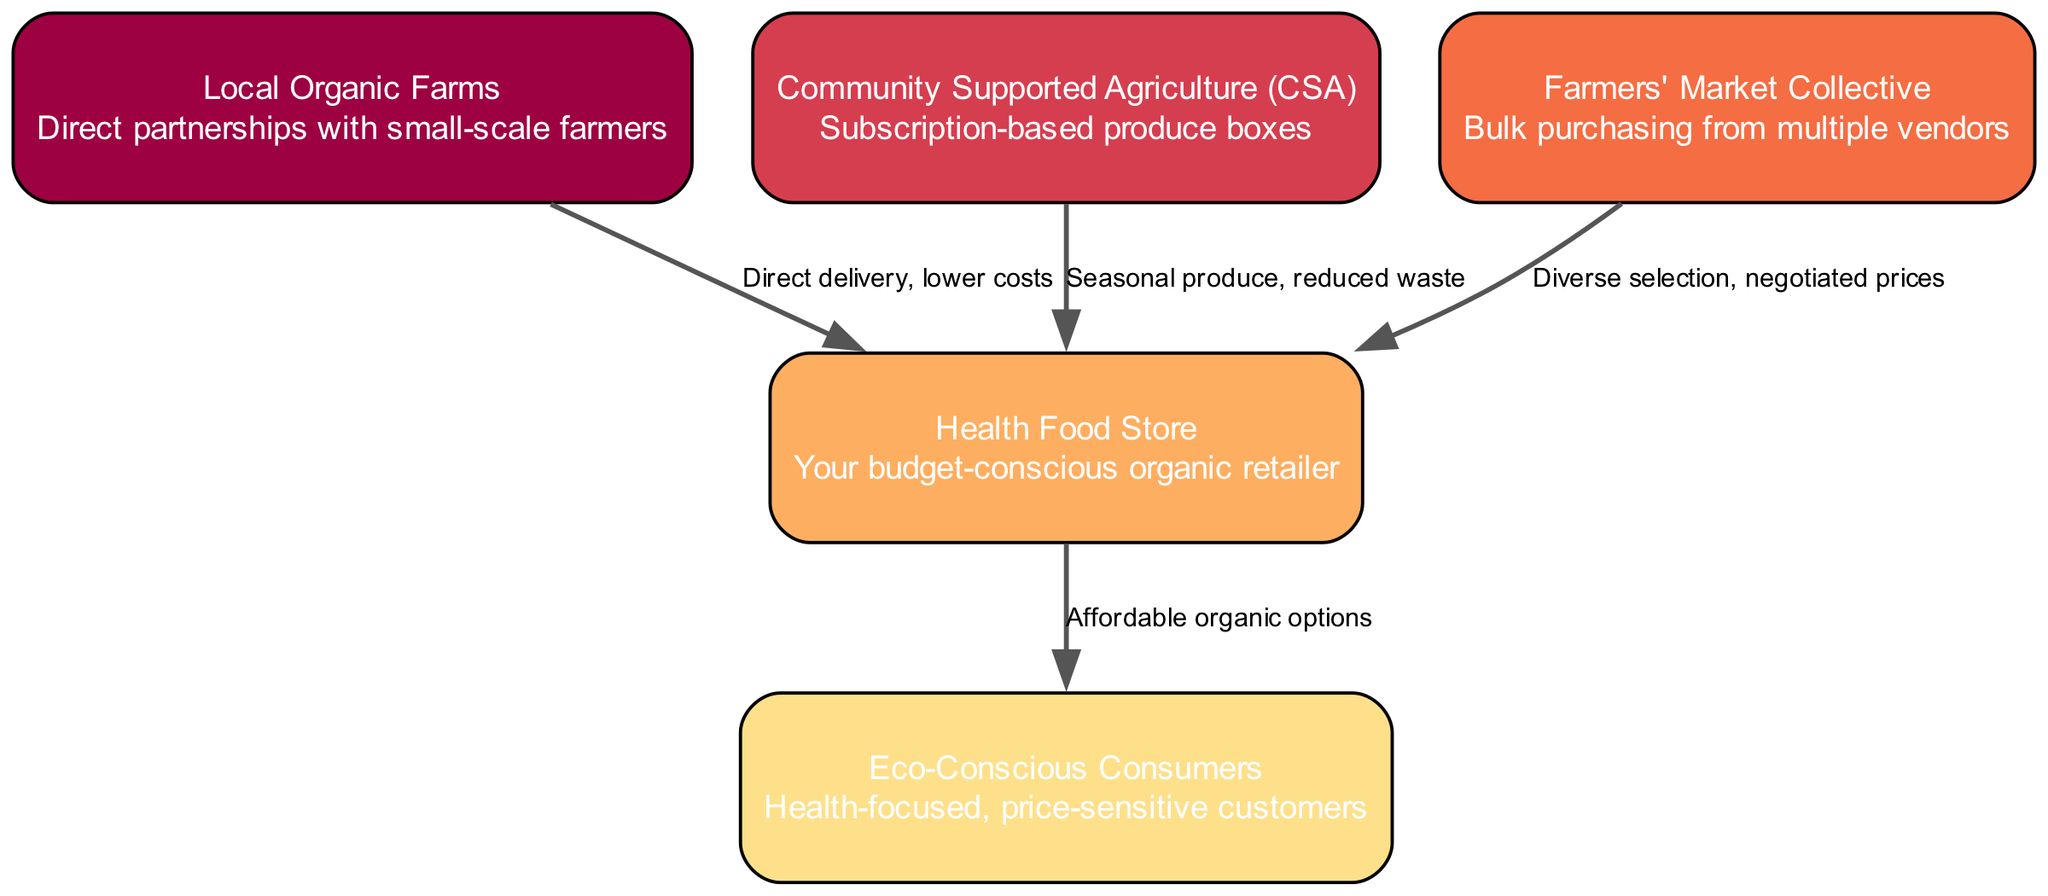What is the first node in the diagram? The first node in the diagram is "Local Organic Farms", as it is listed first in the nodes section.
Answer: Local Organic Farms How many nodes are there in the diagram? There are five nodes represented in the diagram: Local Organic Farms, Community Supported Agriculture, Farmers' Market Collective, Health Food Store, and Eco-Conscious Consumers.
Answer: 5 What relationship does "Local Organic Farms" have with "Health Food Store"? The relationship between "Local Organic Farms" and "Health Food Store" is described as "Direct delivery, lower costs", indicating a direct connection with cost benefits.
Answer: Direct delivery, lower costs What is the connection between "Farmers' Market Collective" and "Health Food Store"? The connection is indicated as "Diverse selection, negotiated prices", which implies that the Farmers' Market Collective provides a variety of products at negotiated rates to the Health Food Store.
Answer: Diverse selection, negotiated prices How many edges are shown in the diagram? The diagram contains four edges, which represent the relationships among the nodes leading to the Health Food Store.
Answer: 4 What do "Eco-Conscious Consumers" receive from the "Health Food Store"? "Eco-Conscious Consumers" receive "Affordable organic options" from the "Health Food Store", which highlights the value offered to customers.
Answer: Affordable organic options What aspect of the produce does "Community Supported Agriculture (CSA)" focus on in its relationship with the "Health Food Store"? The "Community Supported Agriculture (CSA)" focuses on "Seasonal produce, reduced waste", indicating a commitment to sustainability and minimizing waste through seasonal offerings.
Answer: Seasonal produce, reduced waste Which node provides the widest range of produce options to the "Health Food Store"? The "Farmers' Market Collective" provides the widest range of produce options, as it offers a "Diverse selection" to the store, enhancing the product variety available to customers.
Answer: Farmers' Market Collective What kind of consumers are targeted by the "Health Food Store"? The "Health Food Store" targets "Eco-Conscious Consumers", who are described as health-focused and price-sensitive, reflecting their values and purchasing behavior.
Answer: Eco-Conscious Consumers 